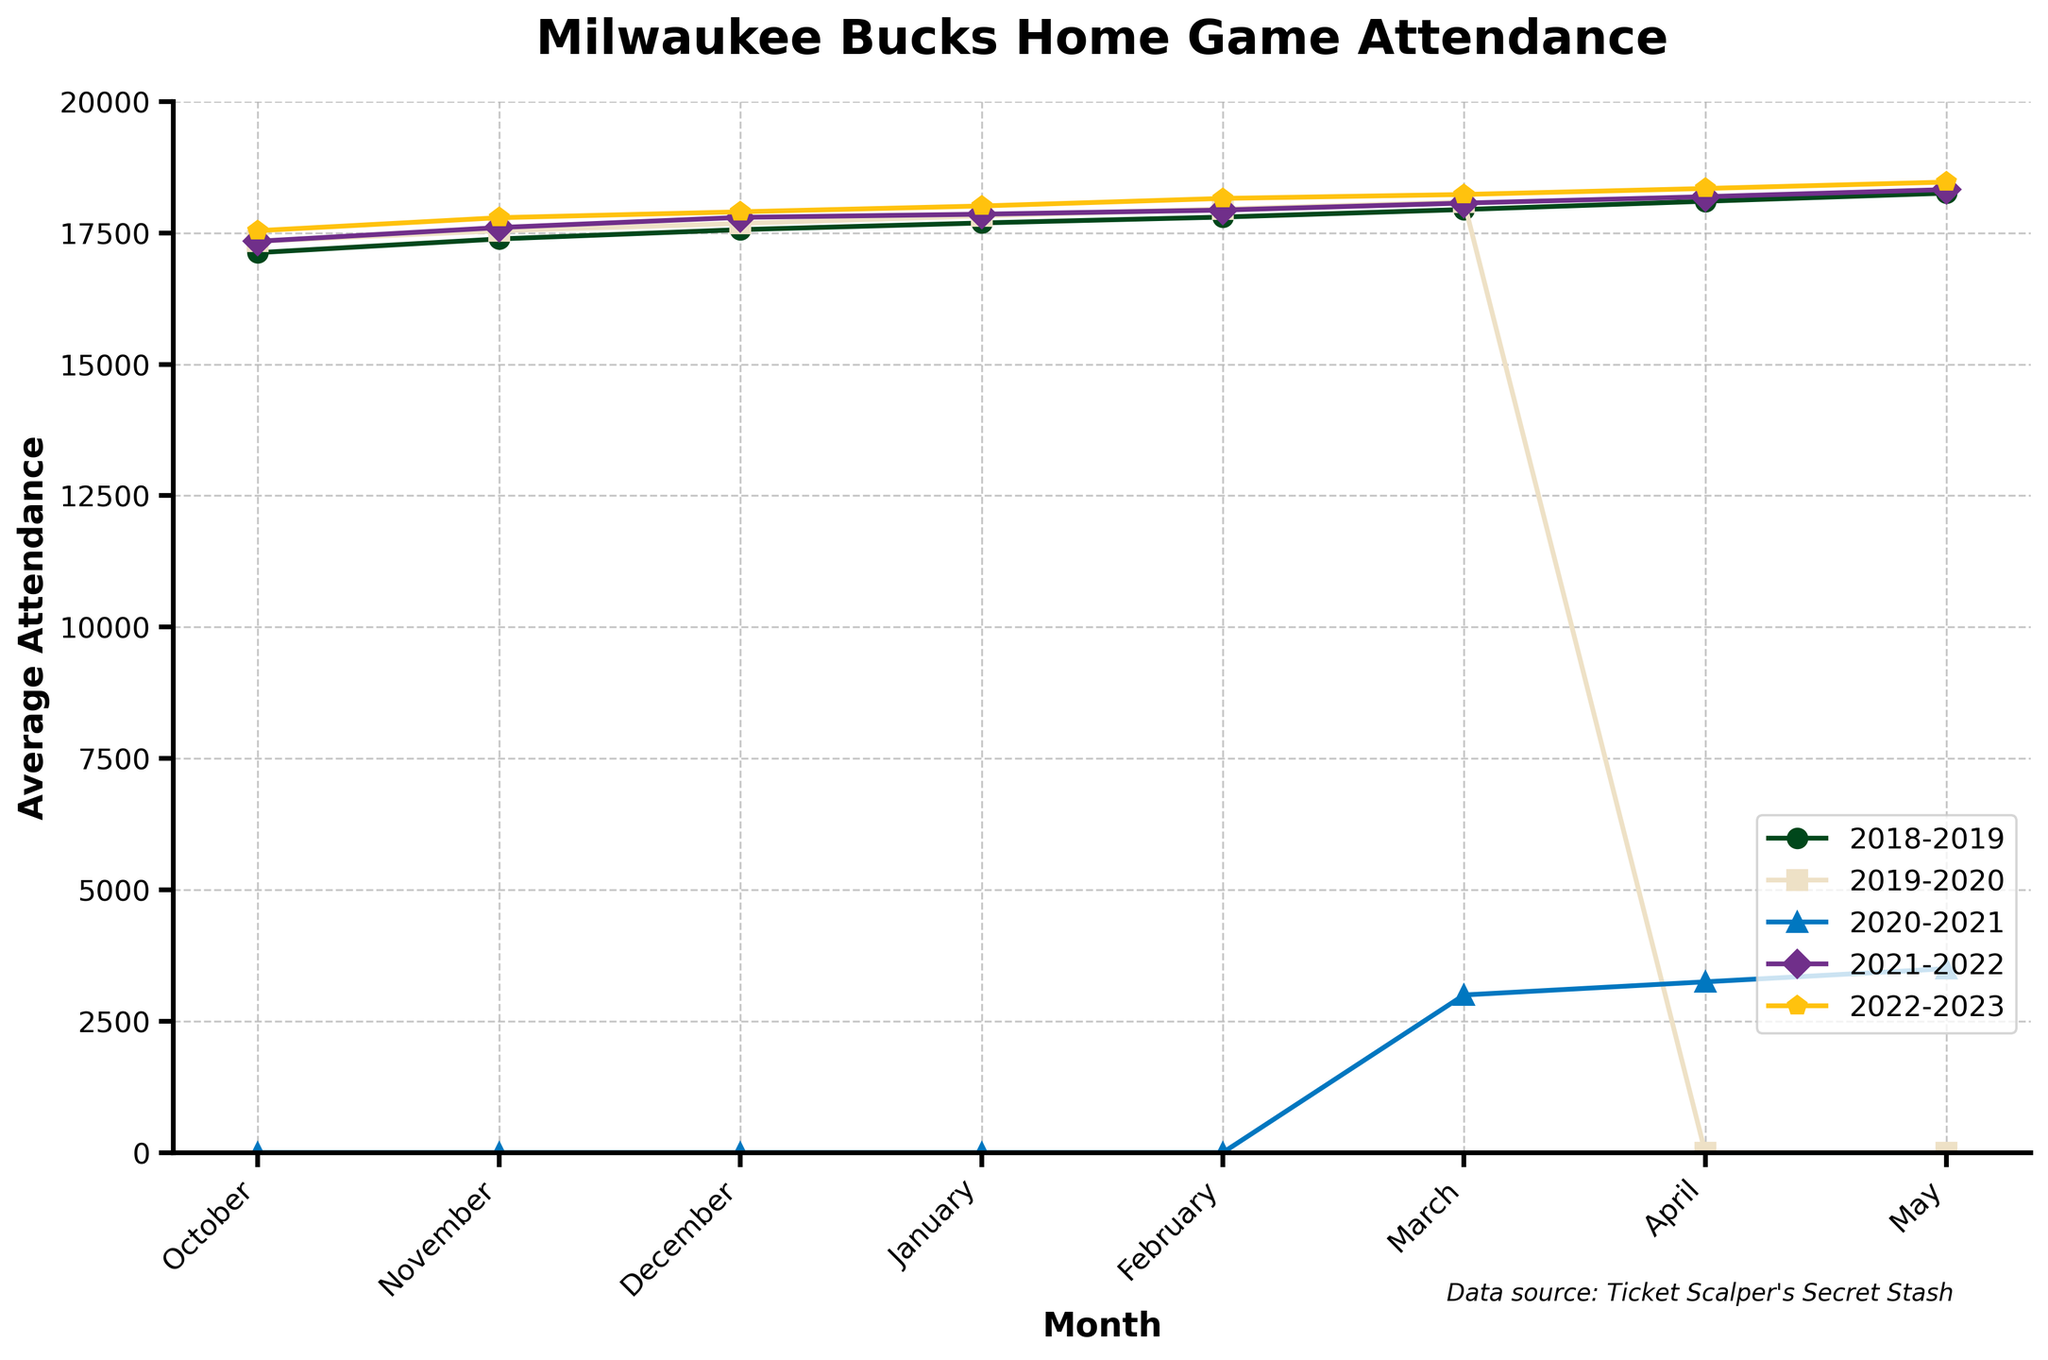Which year had the highest average attendance in February? Compare the points on the plot for all the years in February and find the one with the highest value. The 2022-2023 season's attendance is 18156, which is the highest.
Answer: 2022-2023 What is the difference in attendance between March and April for the year 2020-2021? Locate the values for March and April 2020-2021 and calculate the difference. March's attendance is 3000 and April's is 3250, so the difference is 3250 - 3000 = 250.
Answer: 250 Which months had zero attendance for the 2020-2021 season? Identify the months where the attendance value for 2020-2021 is zero. October, November, December, January, and February all have an attendance of 0.
Answer: October, November, December, January, February How did the attendance in December 2018-2019 compare to December 2022-2023? Compare the attendance values for December in both years. December 2018-2019 is 17562 and December 2022-2023 is 17901, so December 2022-2023 had higher attendance.
Answer: 2022-2023 had higher attendance Which year showed the most significant drop between November and December? Calculate the difference in attendance between November and December for each year, and find the year with the largest decrease. For 2018-2019: 17562 - 17385 = 177; for 2019-2020: 17680 - 17540 = 140; no need for 2020-2021 since it’s zero. The largest drop is in 2019-2020 with a decrease of 140.
Answer: 2019-2020 What is the average attendance for the 2021-2022 season from October to May? Add all available attendance values from October to May for the 2021-2022 season and divide by the number of values. (17341 + 17602 + 17795 + 17856 + 17934 + 18067 + 18189 + 18324) / 8 = 17888.5.
Answer: 17888.5 In which month did the 2021-2022 season have the lowest attendance? Identify the month with the lowest attendance for 2021-2022. The lowest value is in October with an attendance of 17341.
Answer: October Which year had uniform attendance across all months assessed? Check if any year's plot line remains horizontal or relatively constant. 2022-2023 had the most uniform attendance with relatively small increases month over month.
Answer: 2022-2023 What trend is noticeable for the March attendance over the years? Observe the line segments for March across different years. Notice any significant patterns. The most noticeable trend is the sharp dip in March 2020-2021, likely due to an external factor, and then a recovery in subsequent years.
Answer: Decrease in 2020-2021, recovery afterward 